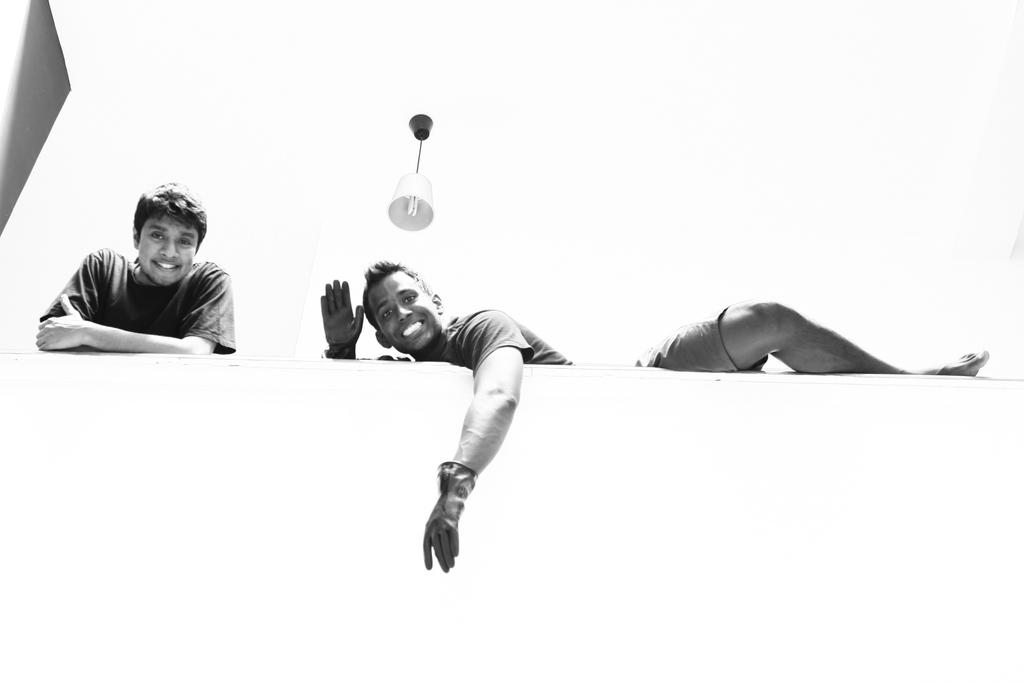What is the color scheme of the image? The image is black and white. Can you describe the position of the people in the image? There is a person standing near a wall, and another person is laying on the wall. What is visible at the top of the image? There is a light visible at the top of the image. What type of wood can be seen in the image? There is no wood present in the image. Is there a window visible in the image? There is no window visible in the image. 